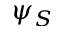<formula> <loc_0><loc_0><loc_500><loc_500>\psi _ { S }</formula> 